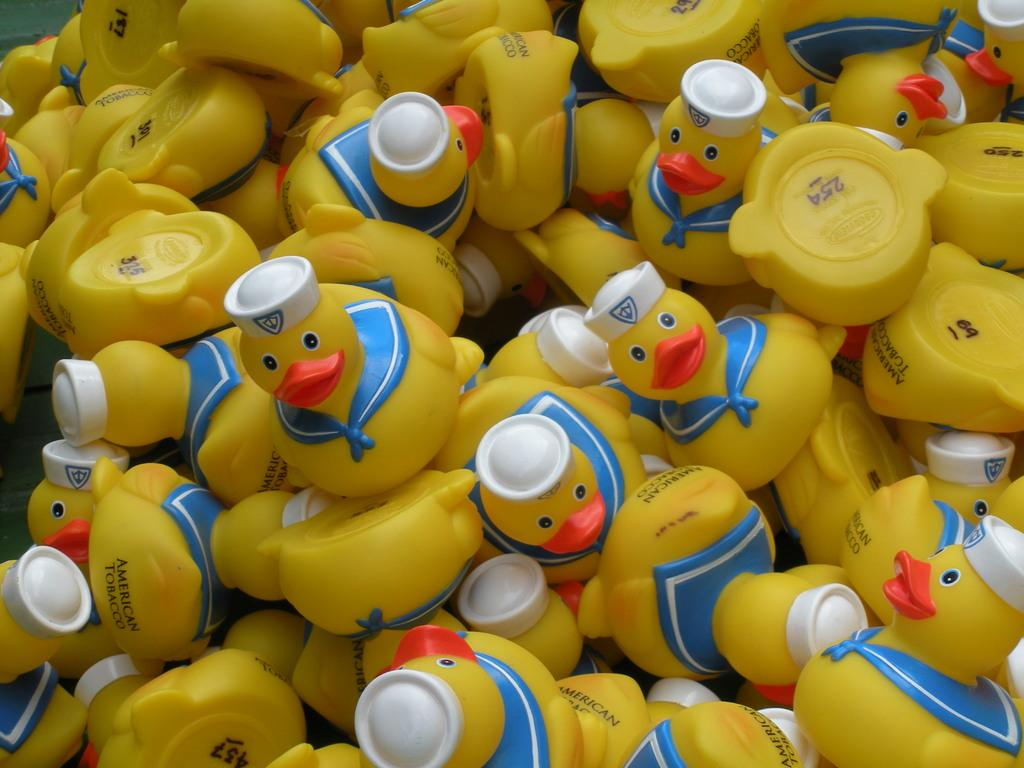What type of objects can be seen in the image? There are toys in the image. What type of chairs are present in the image? There are no chairs present in the image; it only features toys. What type of cream is being used in the meal depicted in the image? There is no meal depicted in the image, so it is impossible to determine what type of cream might be used. 